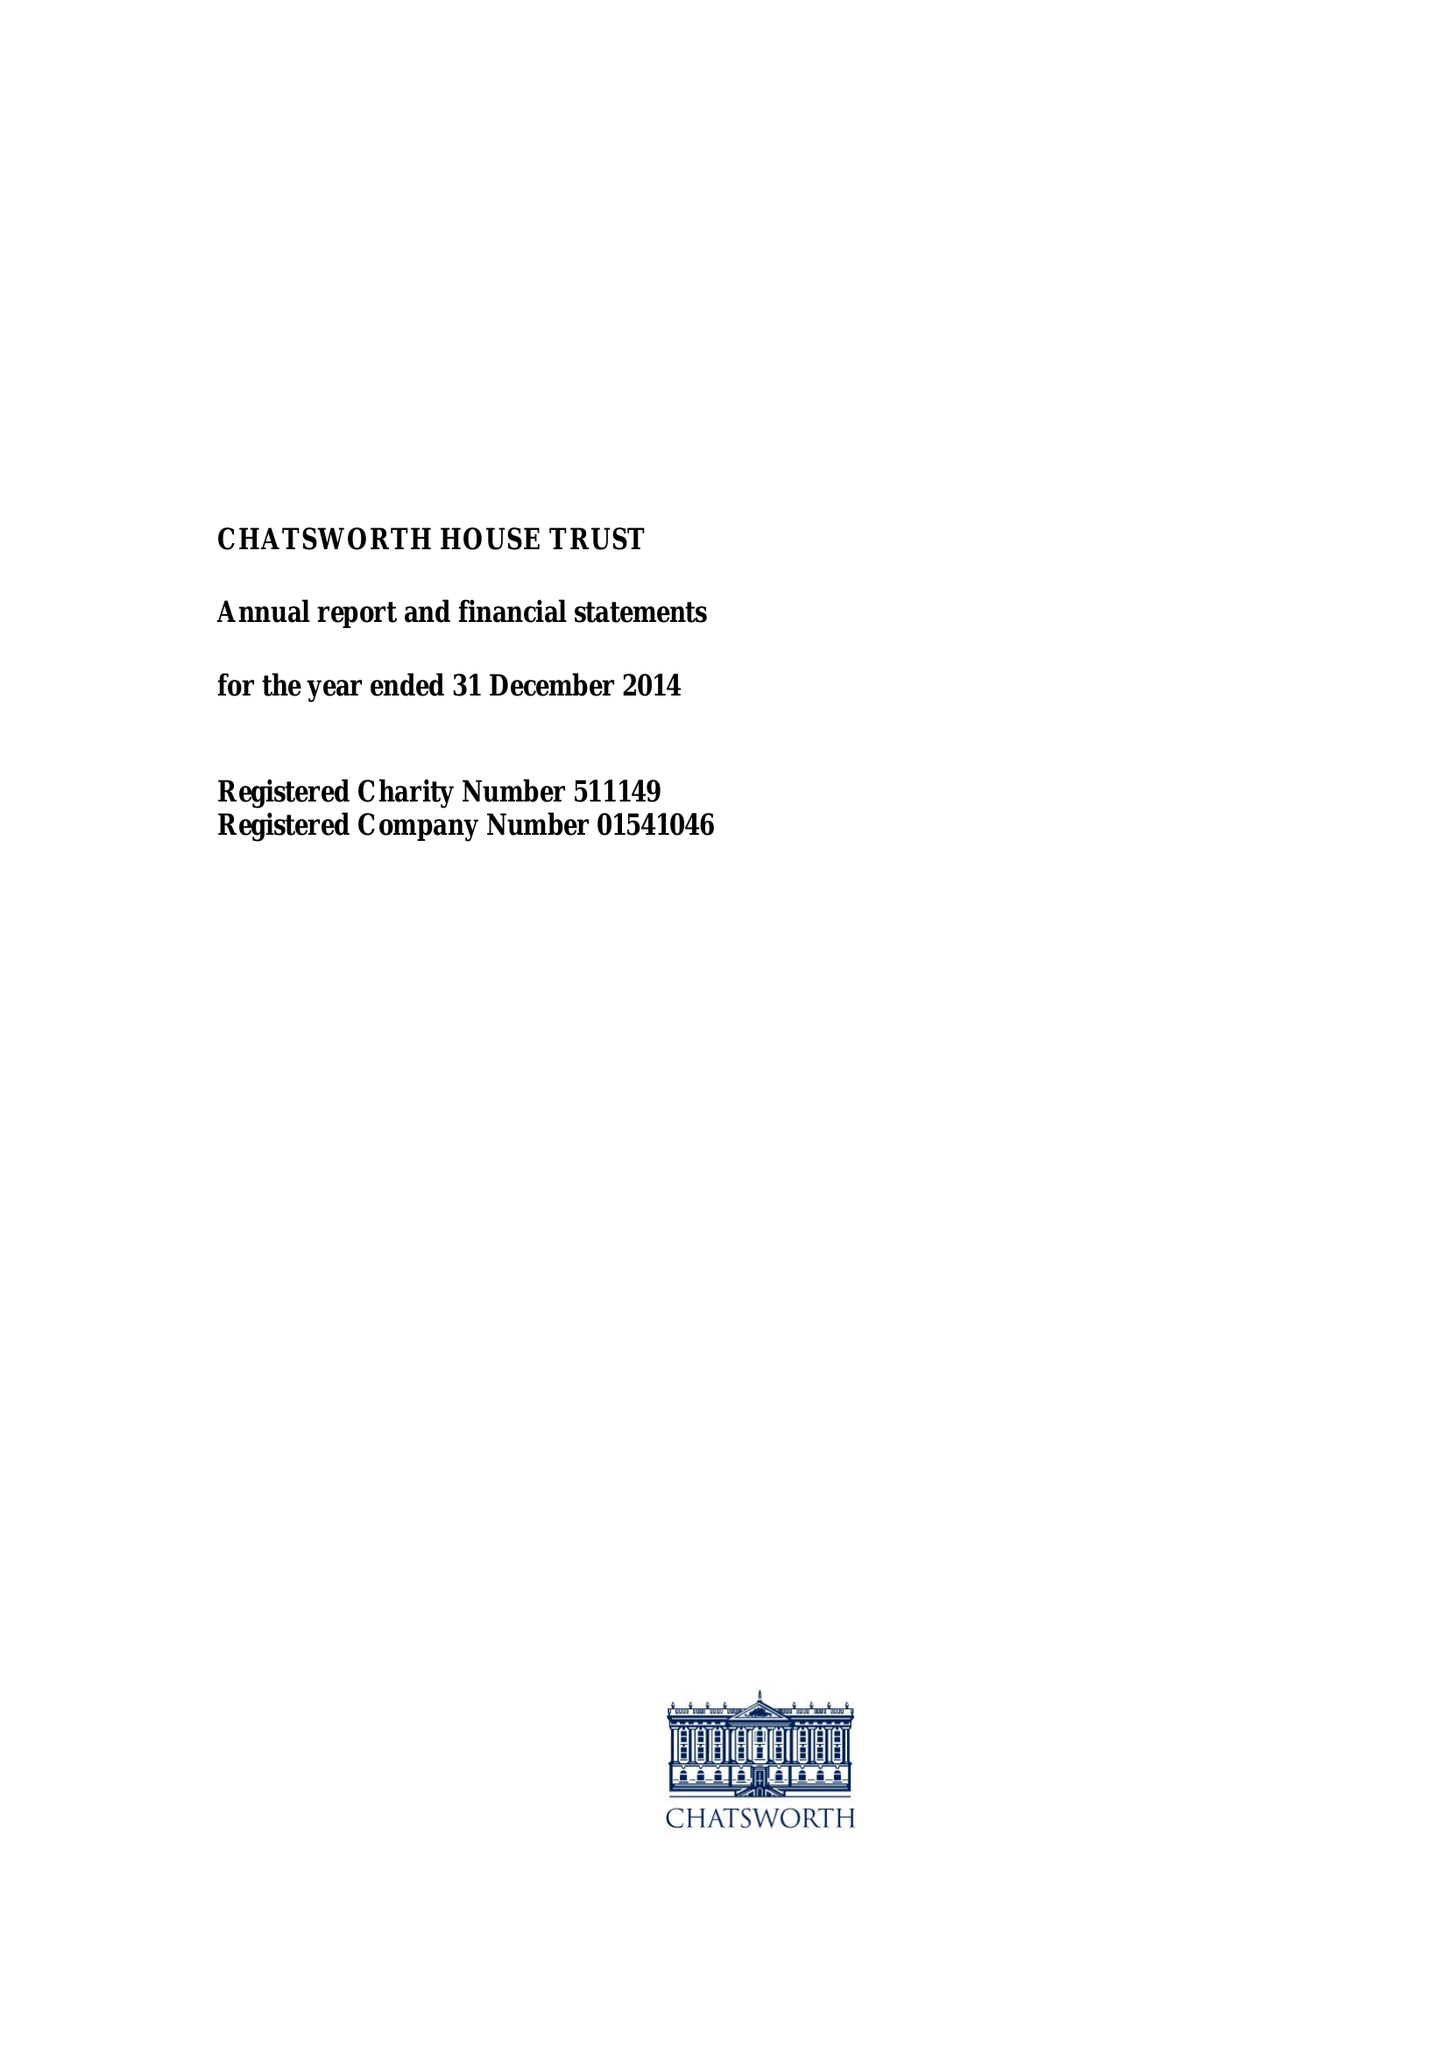What is the value for the report_date?
Answer the question using a single word or phrase. 2014-12-31 